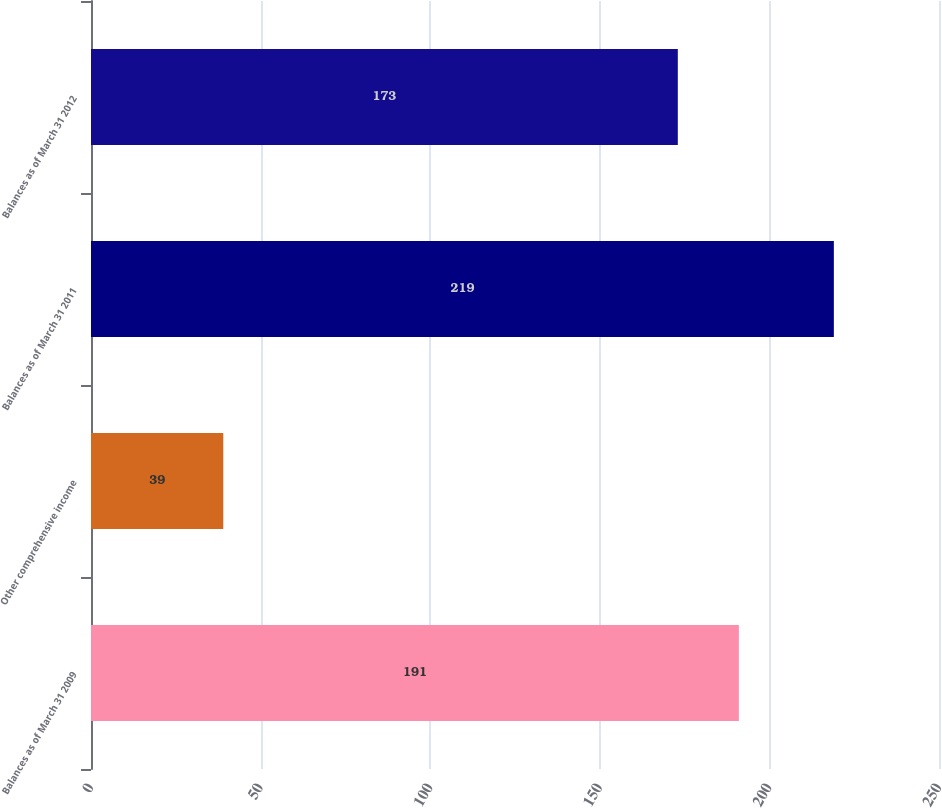Convert chart. <chart><loc_0><loc_0><loc_500><loc_500><bar_chart><fcel>Balances as of March 31 2009<fcel>Other comprehensive income<fcel>Balances as of March 31 2011<fcel>Balances as of March 31 2012<nl><fcel>191<fcel>39<fcel>219<fcel>173<nl></chart> 